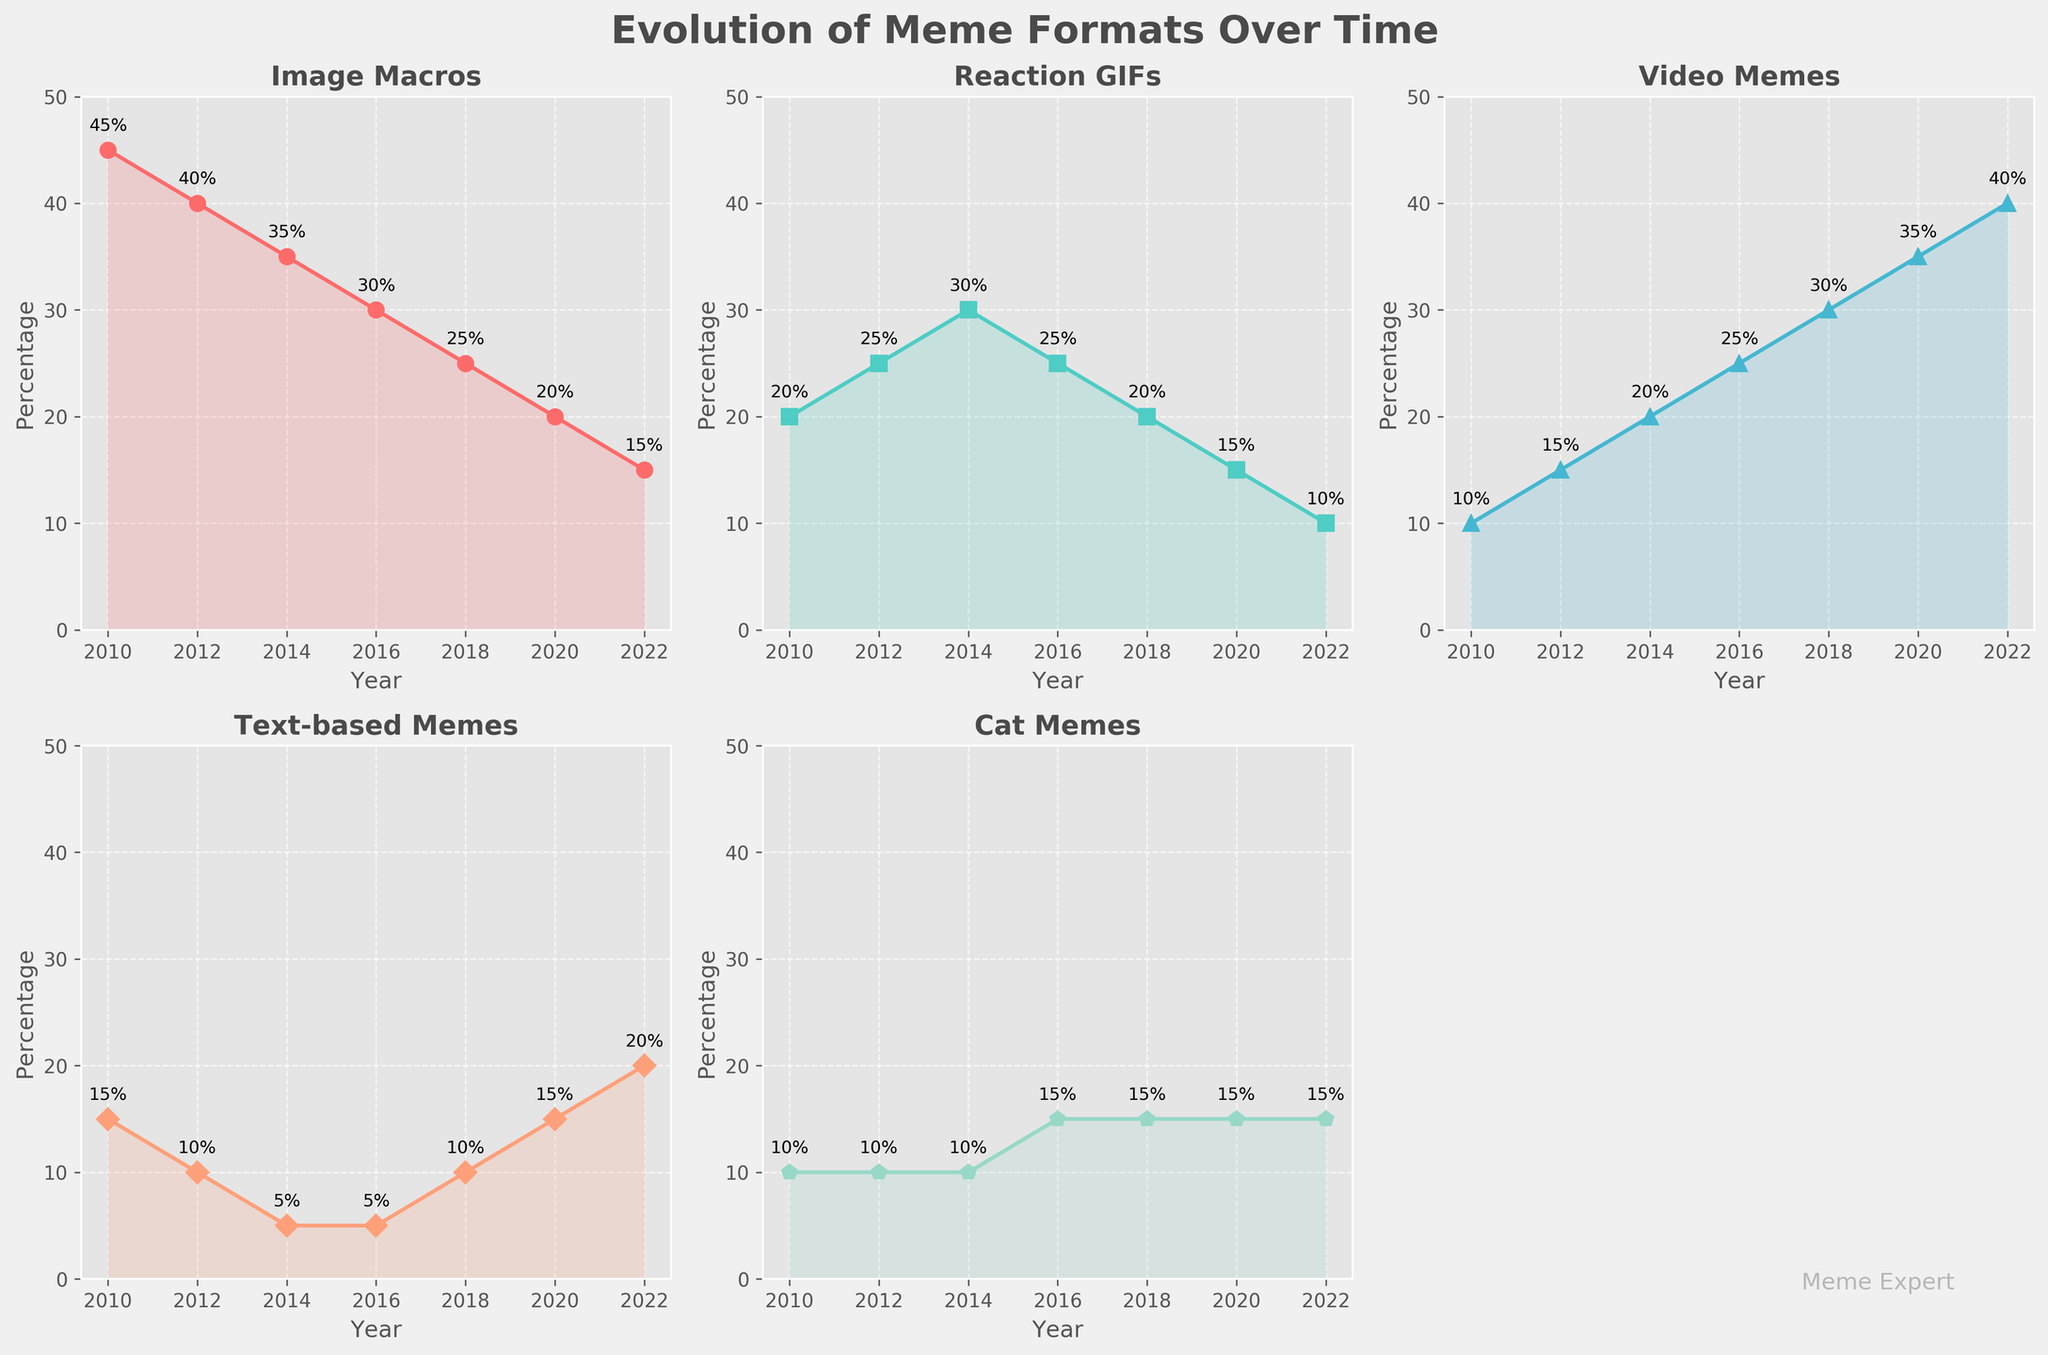What is the title of the figure? The main heading at the top of the subplots provides the title.
Answer: Evolution of Meme Formats Over Time How many meme formats are shown? Each individual subplot represents one type of meme format. By counting these subplots, we can determine the number of meme formats. Note that there are five subplots, as one space is empty.
Answer: Five Which meme format has consistently had a representation of 15% over multiple years? We look at the values annotated within each subplot for occurrences of 15%. "Cat Memes" has 15% representation in 2016, 2018, 2020, and 2022.
Answer: Cat Memes In which year did Image Macros have the highest percentage representation? Examining the annotated points for Image Macros, we find that the highest value is 45% in 2010.
Answer: 2010 How did the popularity of Reaction GIFs change from 2010 to 2022? By tracing the line within the Reaction GIFs subplot and observing the annotated values, we see that it starts at 20% in 2010 and decreases to 10% by 2022.
Answer: It decreased Which meme format saw the most significant increase in percentage from 2010 to 2022? By comparing the first and last data points for each subplot, Video Memes increased from 10% in 2010 to 40% in 2022, an increase of 30%.
Answer: Video Memes What is the sum of the percentages of Text-based Memes in 2014 and 2022? By adding the annotated values for Text-based Memes in 2014 (5%) and 2022 (20%), we get 25%.
Answer: 25% Which meme format had a percentage increase from 2010 to 2016 and then a decrease from 2016 to 2022? By tracing the lines for each format, we see that Video Memes increased from 10% in 2010 to 25% in 2016, then continued to increase, so it doesn't fit. Reaction GIFs increased from 20% in 2010 to 30% in 2014 and decreased down to 10% in 2022, fitting this profile.
Answer: Reaction GIFs What is the difference in percentage of Cat Memes between 2012 and 2020? Observing the annotated values for Cat Memes, we find 10% in 2012 and 15% in 2020, with a difference of 5%.
Answer: 5% Which year saw a tie in the percentage representation between two different meme formats, and which formats were they? Observing each year, 2018 saw both Image Macros and Reaction GIFs at 20% each.
Answer: 2018, Image Macros and Reaction GIFs 